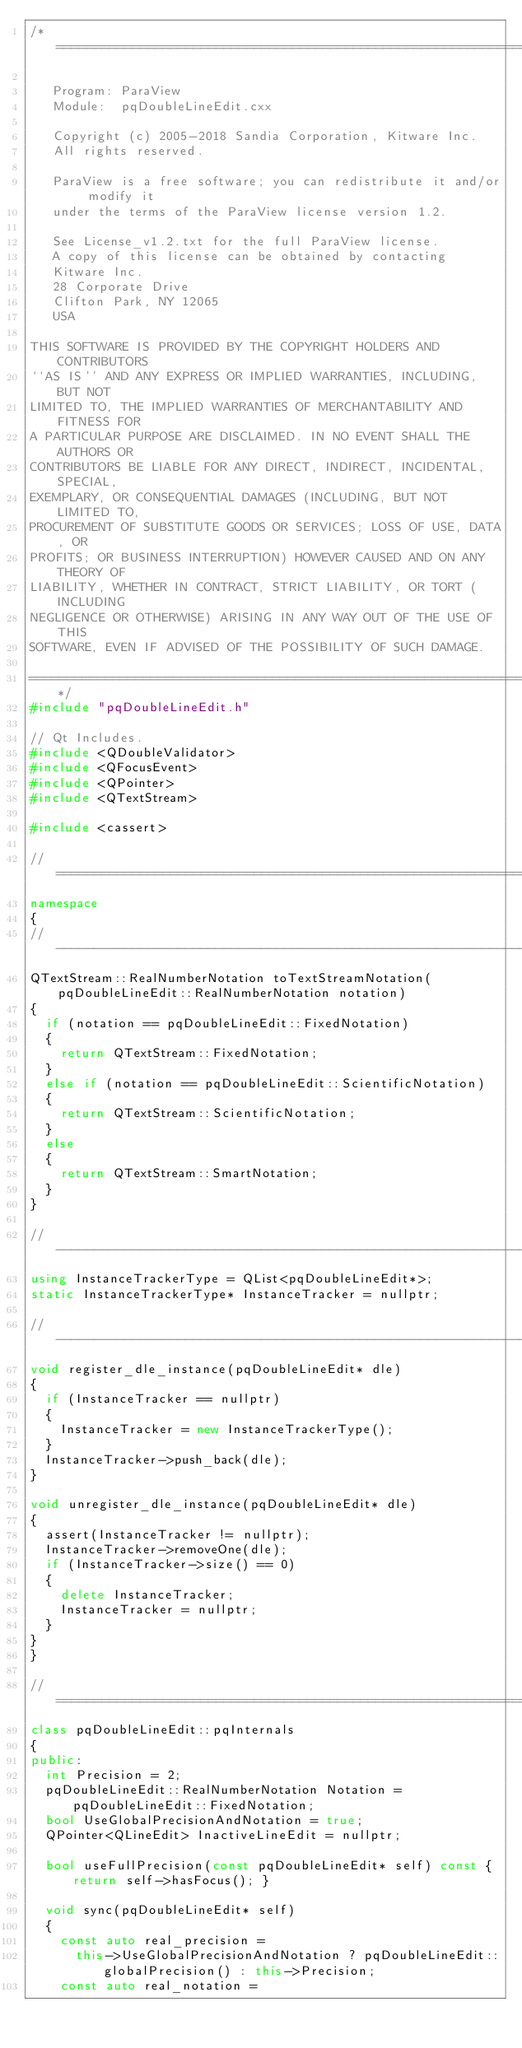<code> <loc_0><loc_0><loc_500><loc_500><_C++_>/*=========================================================================

   Program: ParaView
   Module:  pqDoubleLineEdit.cxx

   Copyright (c) 2005-2018 Sandia Corporation, Kitware Inc.
   All rights reserved.

   ParaView is a free software; you can redistribute it and/or modify it
   under the terms of the ParaView license version 1.2.

   See License_v1.2.txt for the full ParaView license.
   A copy of this license can be obtained by contacting
   Kitware Inc.
   28 Corporate Drive
   Clifton Park, NY 12065
   USA

THIS SOFTWARE IS PROVIDED BY THE COPYRIGHT HOLDERS AND CONTRIBUTORS
``AS IS'' AND ANY EXPRESS OR IMPLIED WARRANTIES, INCLUDING, BUT NOT
LIMITED TO, THE IMPLIED WARRANTIES OF MERCHANTABILITY AND FITNESS FOR
A PARTICULAR PURPOSE ARE DISCLAIMED. IN NO EVENT SHALL THE AUTHORS OR
CONTRIBUTORS BE LIABLE FOR ANY DIRECT, INDIRECT, INCIDENTAL, SPECIAL,
EXEMPLARY, OR CONSEQUENTIAL DAMAGES (INCLUDING, BUT NOT LIMITED TO,
PROCUREMENT OF SUBSTITUTE GOODS OR SERVICES; LOSS OF USE, DATA, OR
PROFITS; OR BUSINESS INTERRUPTION) HOWEVER CAUSED AND ON ANY THEORY OF
LIABILITY, WHETHER IN CONTRACT, STRICT LIABILITY, OR TORT (INCLUDING
NEGLIGENCE OR OTHERWISE) ARISING IN ANY WAY OUT OF THE USE OF THIS
SOFTWARE, EVEN IF ADVISED OF THE POSSIBILITY OF SUCH DAMAGE.

========================================================================*/
#include "pqDoubleLineEdit.h"

// Qt Includes.
#include <QDoubleValidator>
#include <QFocusEvent>
#include <QPointer>
#include <QTextStream>

#include <cassert>

//=============================================================================
namespace
{
//-----------------------------------------------------------------------------
QTextStream::RealNumberNotation toTextStreamNotation(pqDoubleLineEdit::RealNumberNotation notation)
{
  if (notation == pqDoubleLineEdit::FixedNotation)
  {
    return QTextStream::FixedNotation;
  }
  else if (notation == pqDoubleLineEdit::ScientificNotation)
  {
    return QTextStream::ScientificNotation;
  }
  else
  {
    return QTextStream::SmartNotation;
  }
}

//-----------------------------------------------------------------------------
using InstanceTrackerType = QList<pqDoubleLineEdit*>;
static InstanceTrackerType* InstanceTracker = nullptr;

//-----------------------------------------------------------------------------
void register_dle_instance(pqDoubleLineEdit* dle)
{
  if (InstanceTracker == nullptr)
  {
    InstanceTracker = new InstanceTrackerType();
  }
  InstanceTracker->push_back(dle);
}

void unregister_dle_instance(pqDoubleLineEdit* dle)
{
  assert(InstanceTracker != nullptr);
  InstanceTracker->removeOne(dle);
  if (InstanceTracker->size() == 0)
  {
    delete InstanceTracker;
    InstanceTracker = nullptr;
  }
}
}

//=============================================================================
class pqDoubleLineEdit::pqInternals
{
public:
  int Precision = 2;
  pqDoubleLineEdit::RealNumberNotation Notation = pqDoubleLineEdit::FixedNotation;
  bool UseGlobalPrecisionAndNotation = true;
  QPointer<QLineEdit> InactiveLineEdit = nullptr;

  bool useFullPrecision(const pqDoubleLineEdit* self) const { return self->hasFocus(); }

  void sync(pqDoubleLineEdit* self)
  {
    const auto real_precision =
      this->UseGlobalPrecisionAndNotation ? pqDoubleLineEdit::globalPrecision() : this->Precision;
    const auto real_notation =</code> 